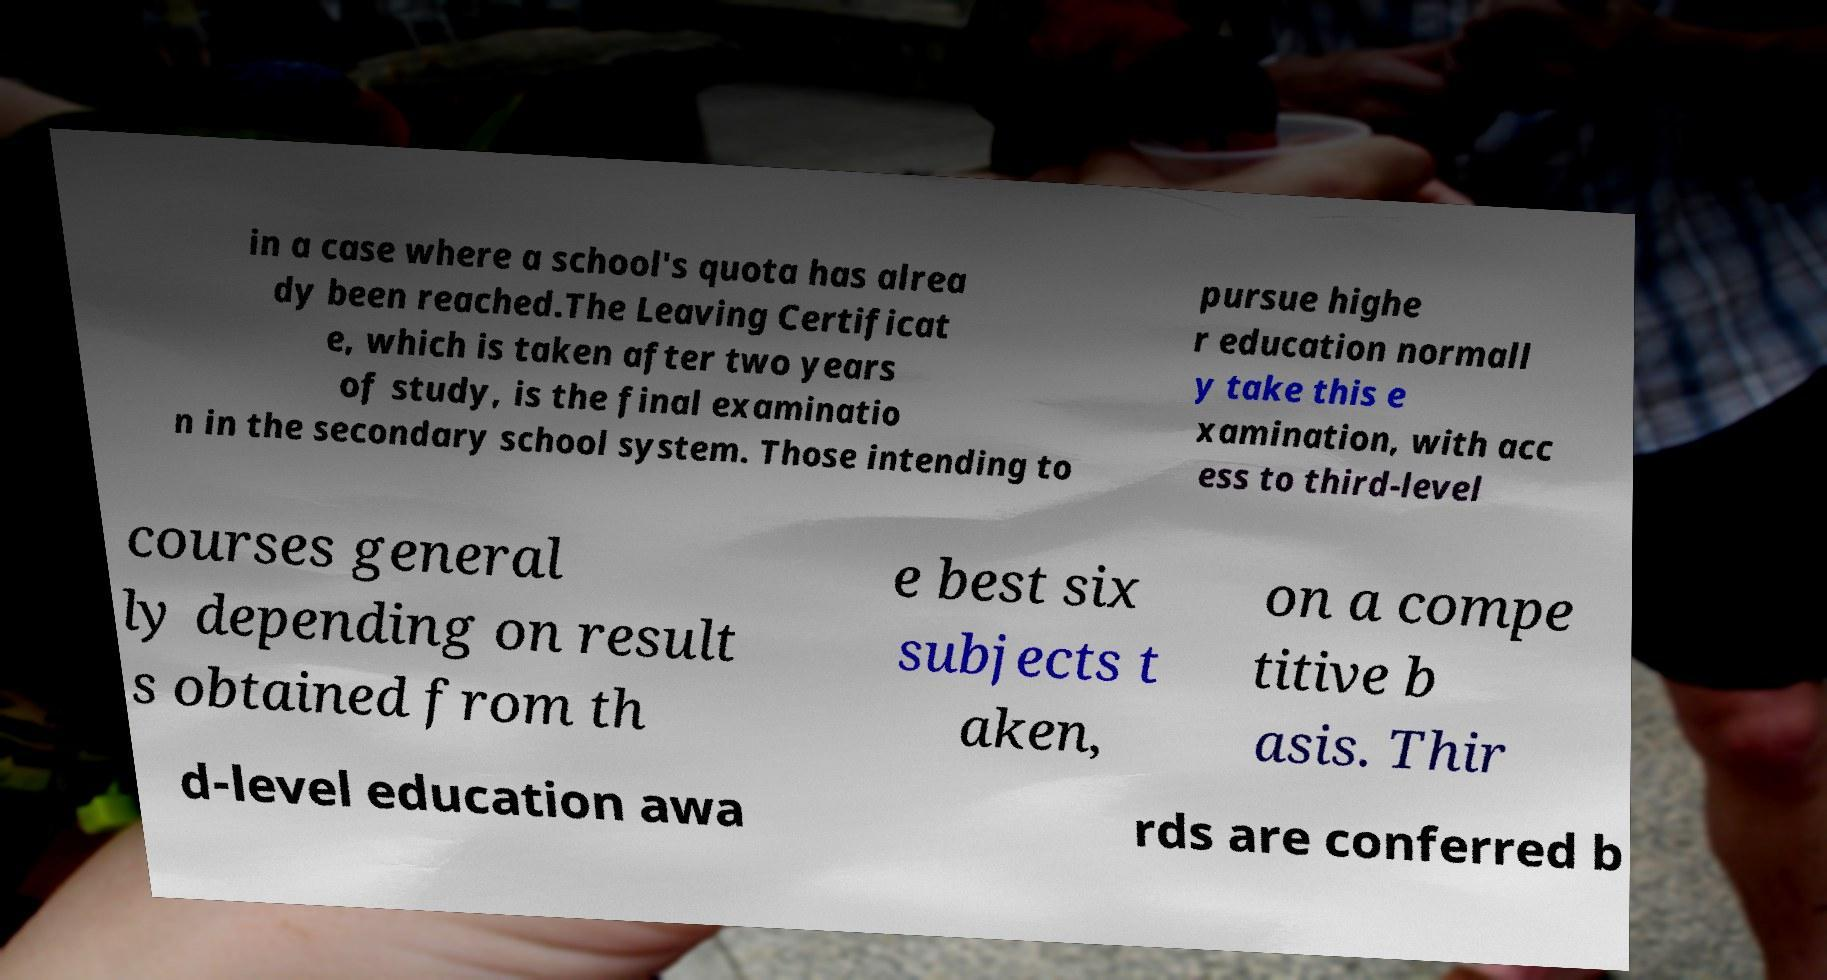There's text embedded in this image that I need extracted. Can you transcribe it verbatim? in a case where a school's quota has alrea dy been reached.The Leaving Certificat e, which is taken after two years of study, is the final examinatio n in the secondary school system. Those intending to pursue highe r education normall y take this e xamination, with acc ess to third-level courses general ly depending on result s obtained from th e best six subjects t aken, on a compe titive b asis. Thir d-level education awa rds are conferred b 